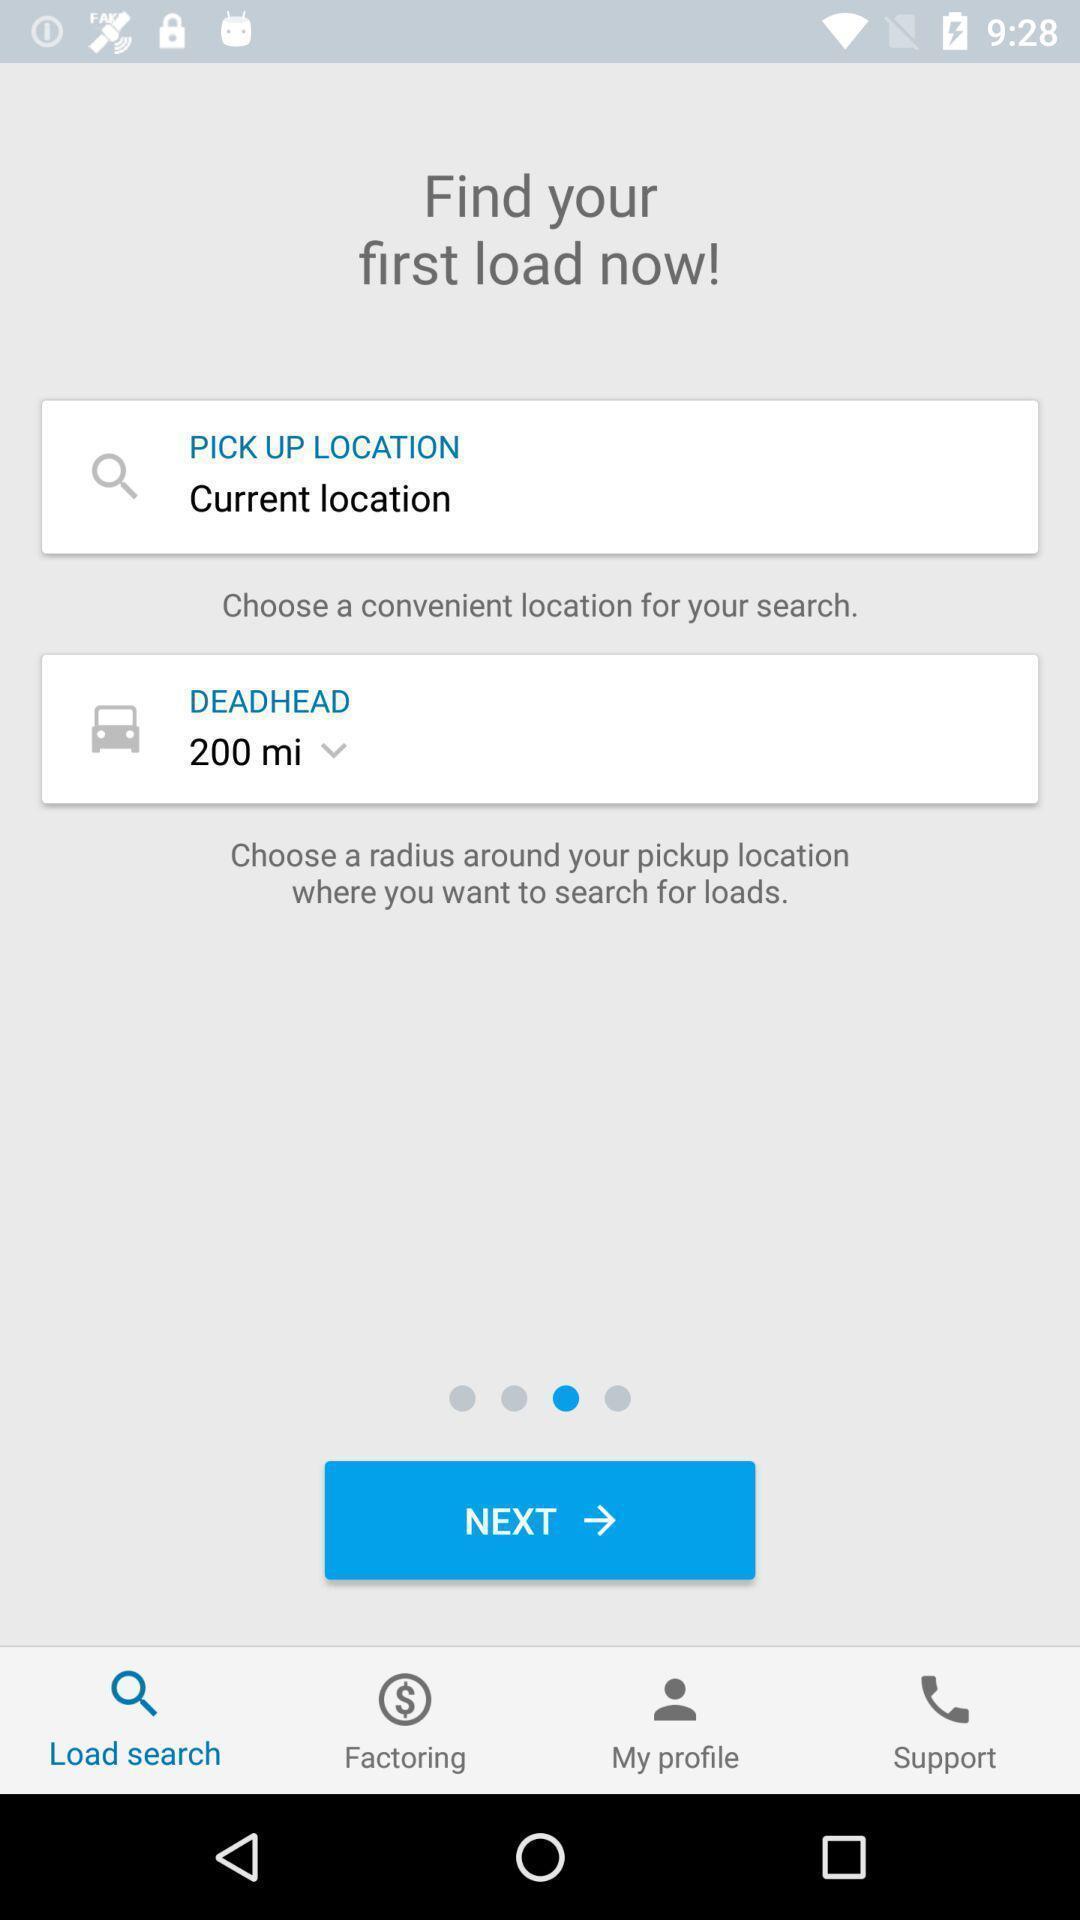Give me a narrative description of this picture. Screen displaying of a ride application. 